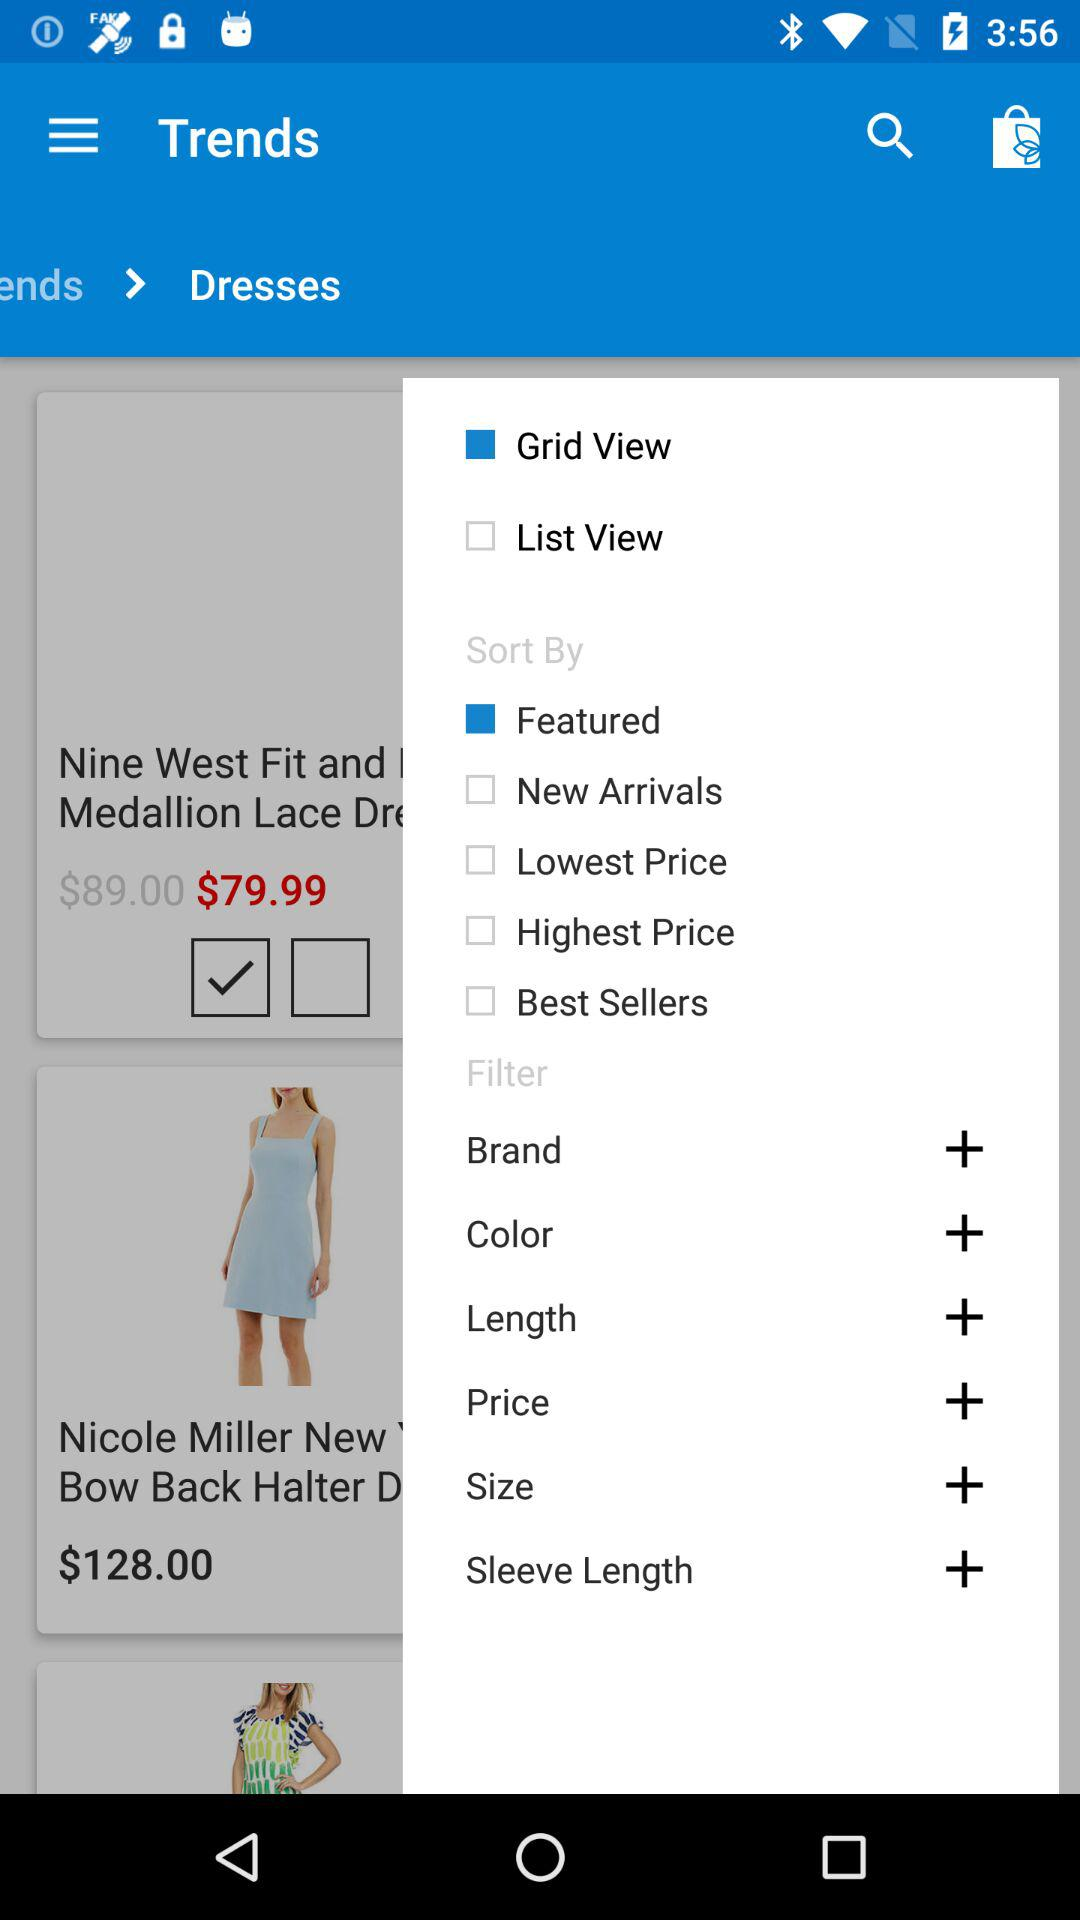Which option is selected in "Sort By"? The selected option is "Featured". 